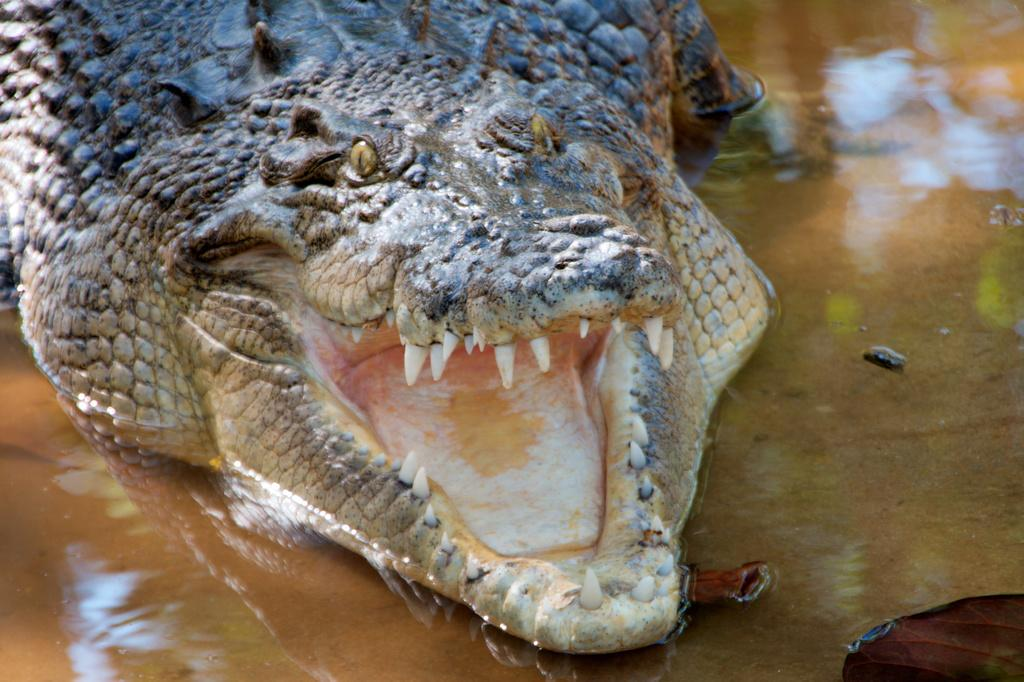What animal is in the image? There is a crocodile in the image. What is the crocodile doing in the image? The crocodile has its mouth open in the image. Where is the crocodile located in the image? The crocodile is in the water in the image. What type of branch is the doctor holding in the image? There is no doctor or branch present in the image; it features a crocodile with its mouth open in the water. 